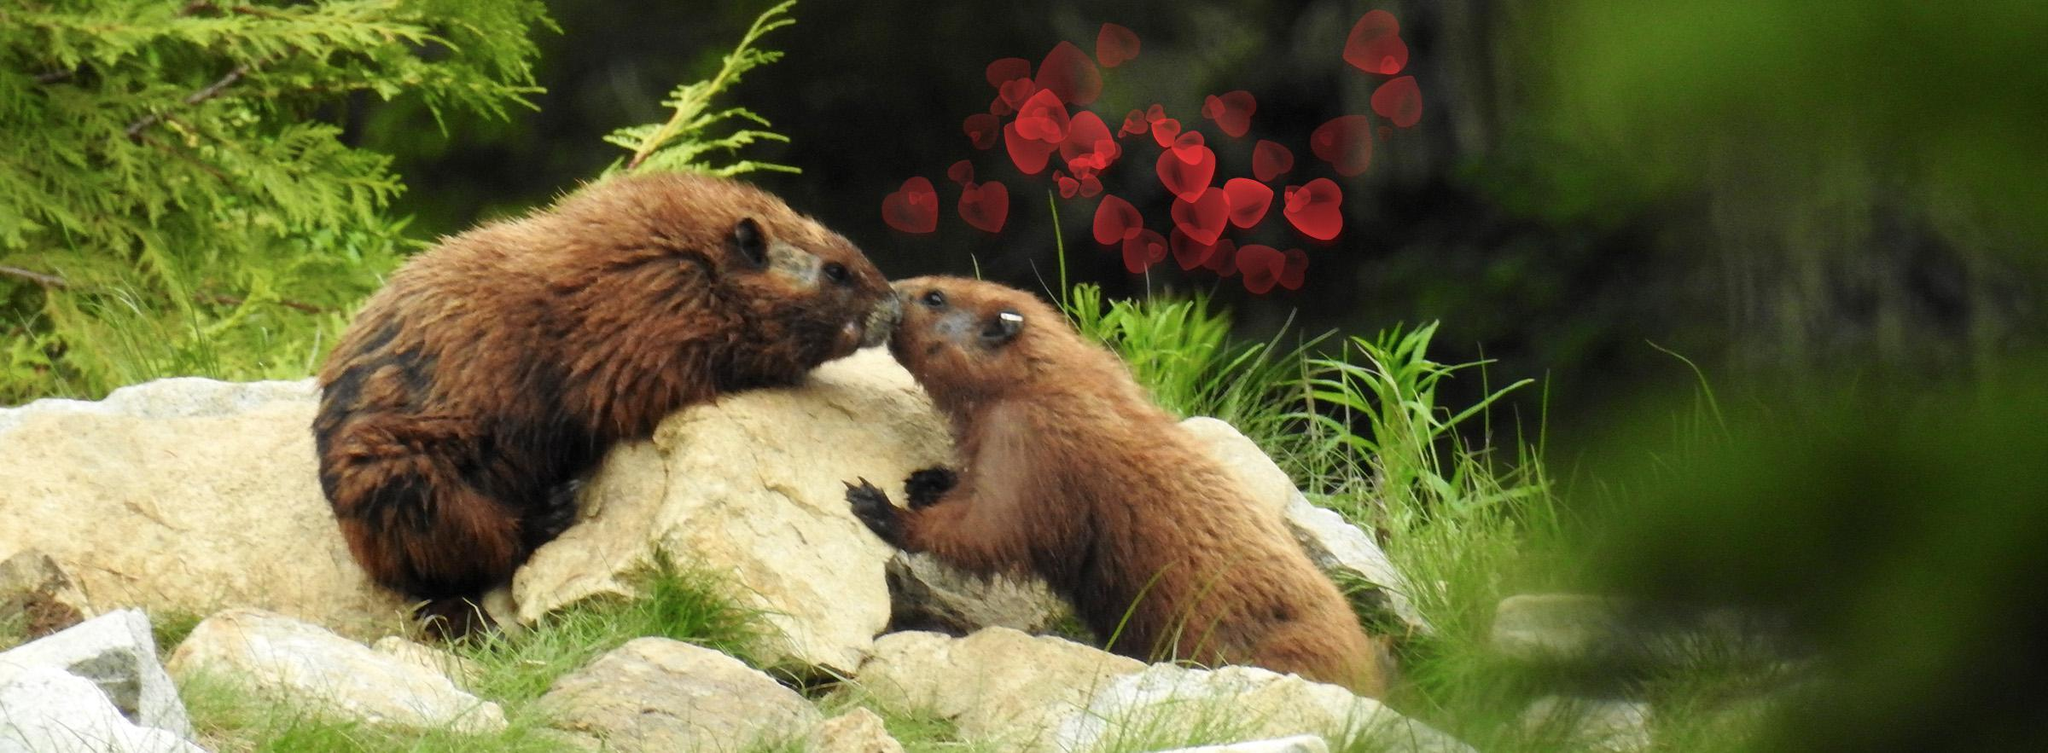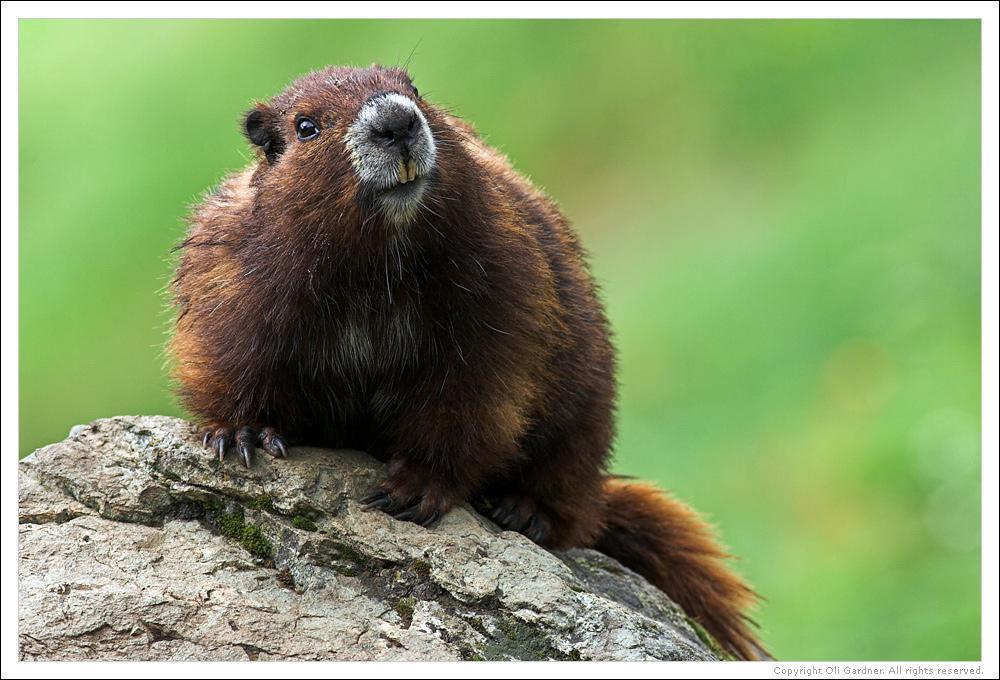The first image is the image on the left, the second image is the image on the right. Considering the images on both sides, is "One image shows two marmots posed face-to-face, and the other image shows one marmot on all fours on a rock." valid? Answer yes or no. Yes. The first image is the image on the left, the second image is the image on the right. Assess this claim about the two images: "There are three marmots.". Correct or not? Answer yes or no. Yes. 